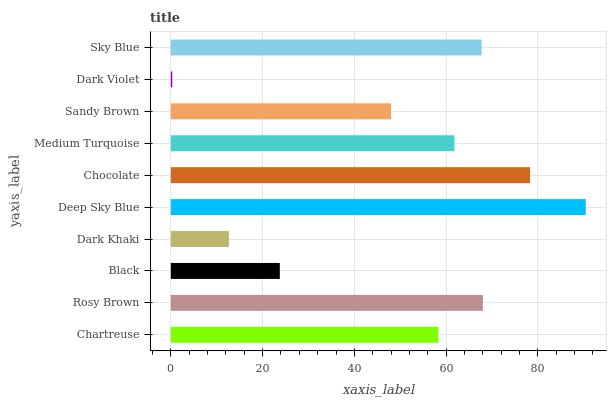Is Dark Violet the minimum?
Answer yes or no. Yes. Is Deep Sky Blue the maximum?
Answer yes or no. Yes. Is Rosy Brown the minimum?
Answer yes or no. No. Is Rosy Brown the maximum?
Answer yes or no. No. Is Rosy Brown greater than Chartreuse?
Answer yes or no. Yes. Is Chartreuse less than Rosy Brown?
Answer yes or no. Yes. Is Chartreuse greater than Rosy Brown?
Answer yes or no. No. Is Rosy Brown less than Chartreuse?
Answer yes or no. No. Is Medium Turquoise the high median?
Answer yes or no. Yes. Is Chartreuse the low median?
Answer yes or no. Yes. Is Sandy Brown the high median?
Answer yes or no. No. Is Chocolate the low median?
Answer yes or no. No. 